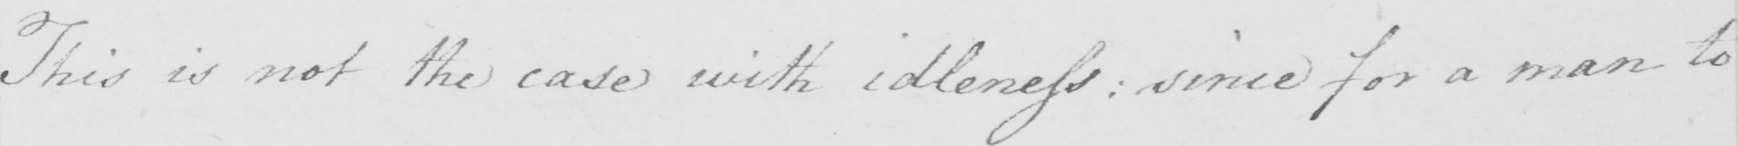What does this handwritten line say? This is not the case with idleness :  since for a man to 